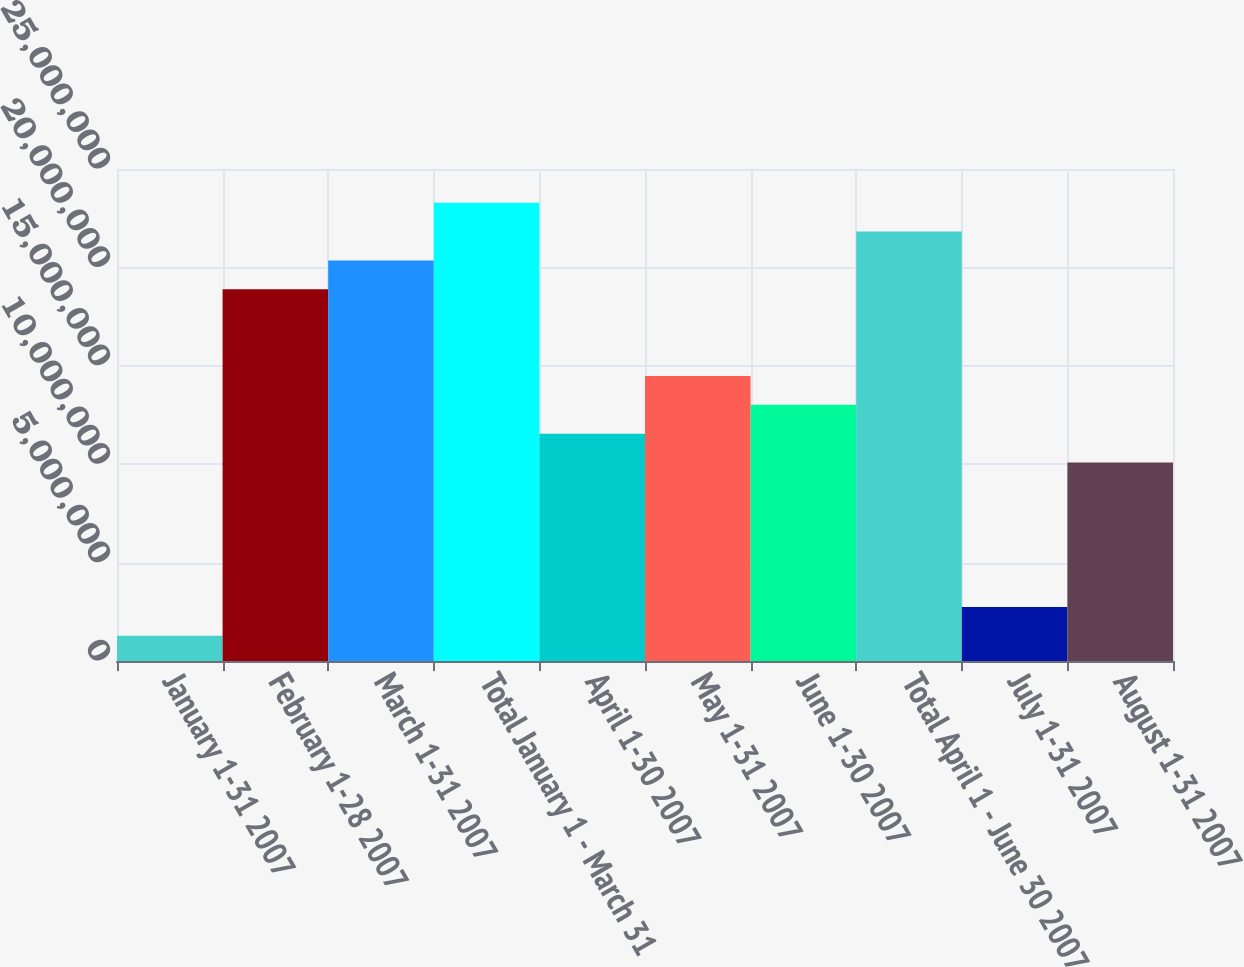Convert chart to OTSL. <chart><loc_0><loc_0><loc_500><loc_500><bar_chart><fcel>January 1-31 2007<fcel>February 1-28 2007<fcel>March 1-31 2007<fcel>Total January 1 - March 31<fcel>April 1-30 2007<fcel>May 1-31 2007<fcel>June 1-30 2007<fcel>Total April 1 - June 30 2007<fcel>July 1-31 2007<fcel>August 1-31 2007<nl><fcel>1.2772e+06<fcel>1.88862e+07<fcel>2.03537e+07<fcel>2.32885e+07<fcel>1.15491e+07<fcel>1.4484e+07<fcel>1.30166e+07<fcel>2.18211e+07<fcel>2.74462e+06<fcel>1.00817e+07<nl></chart> 